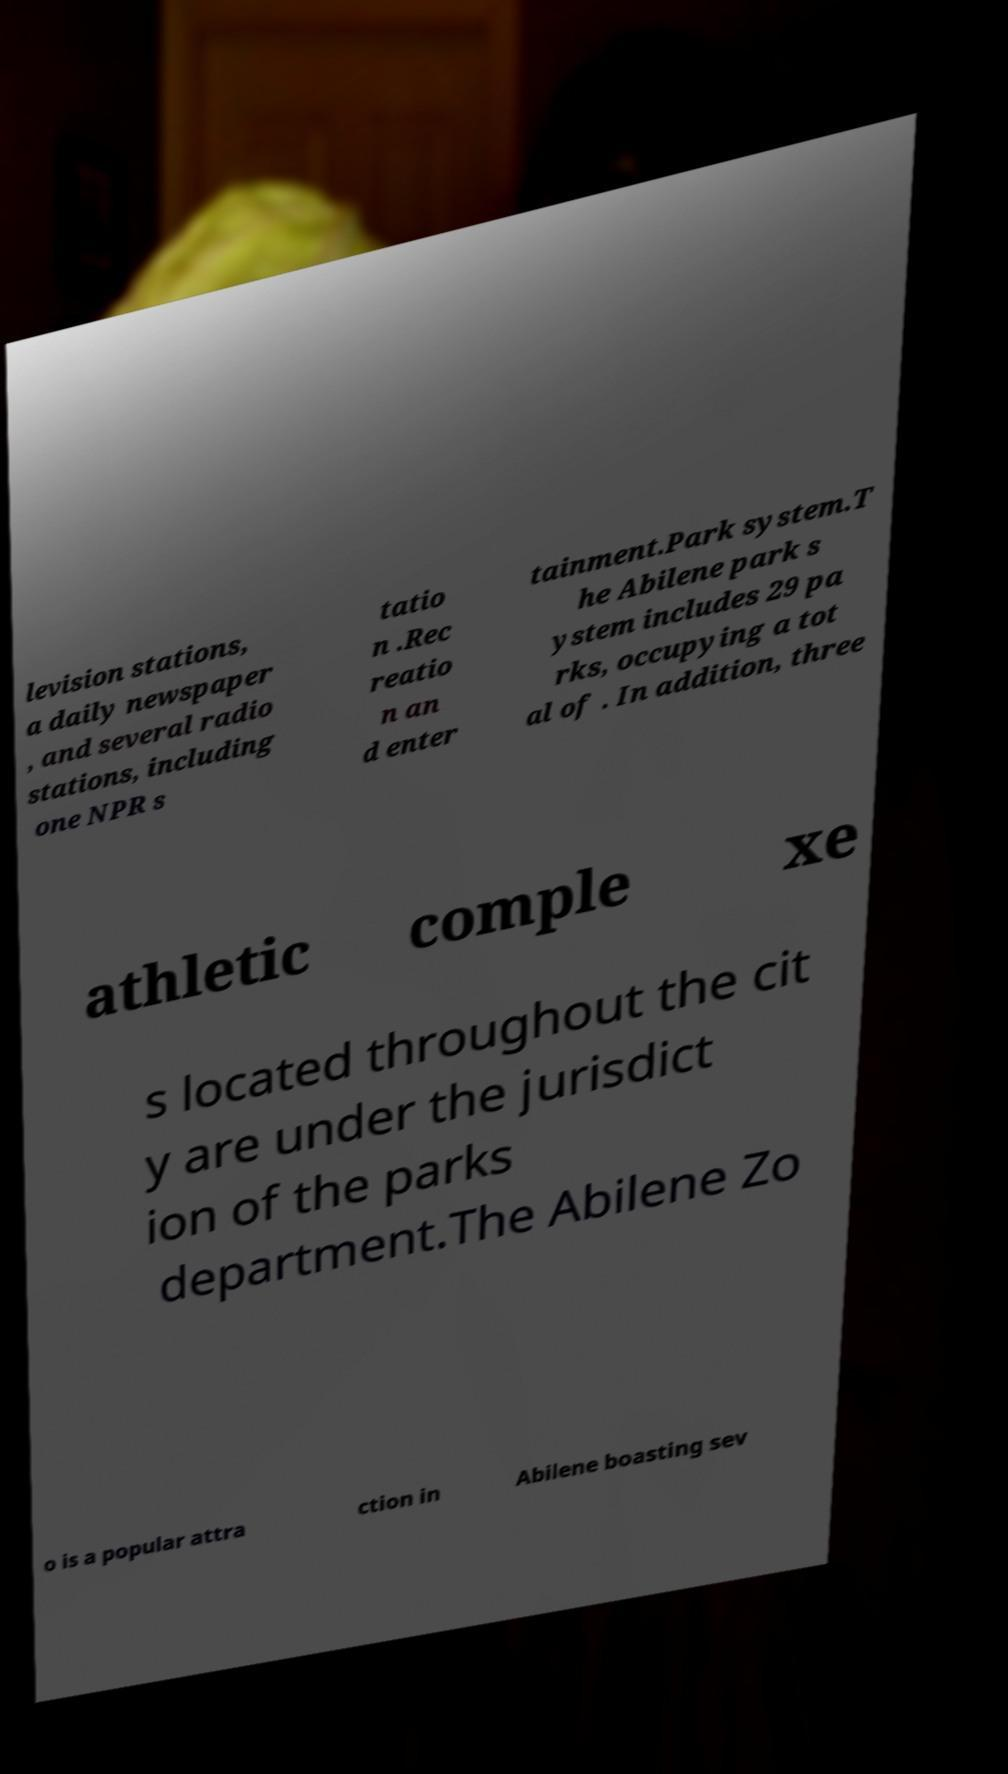Please identify and transcribe the text found in this image. levision stations, a daily newspaper , and several radio stations, including one NPR s tatio n .Rec reatio n an d enter tainment.Park system.T he Abilene park s ystem includes 29 pa rks, occupying a tot al of . In addition, three athletic comple xe s located throughout the cit y are under the jurisdict ion of the parks department.The Abilene Zo o is a popular attra ction in Abilene boasting sev 